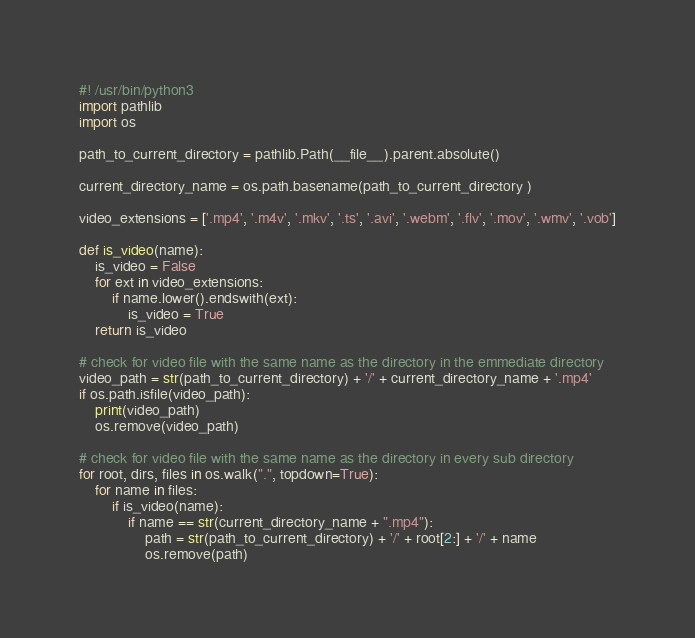<code> <loc_0><loc_0><loc_500><loc_500><_Python_>#! /usr/bin/python3
import pathlib
import os

path_to_current_directory = pathlib.Path(__file__).parent.absolute()

current_directory_name = os.path.basename(path_to_current_directory )

video_extensions = ['.mp4', '.m4v', '.mkv', '.ts', '.avi', '.webm', '.flv', '.mov', '.wmv', '.vob']

def is_video(name):
    is_video = False
    for ext in video_extensions:
        if name.lower().endswith(ext):
            is_video = True
    return is_video

# check for video file with the same name as the directory in the emmediate directory
video_path = str(path_to_current_directory) + '/' + current_directory_name + '.mp4'
if os.path.isfile(video_path):
    print(video_path)
    os.remove(video_path)

# check for video file with the same name as the directory in every sub directory
for root, dirs, files in os.walk(".", topdown=True):
    for name in files:
        if is_video(name):
            if name == str(current_directory_name + ".mp4"):
                path = str(path_to_current_directory) + '/' + root[2:] + '/' + name
                os.remove(path)</code> 